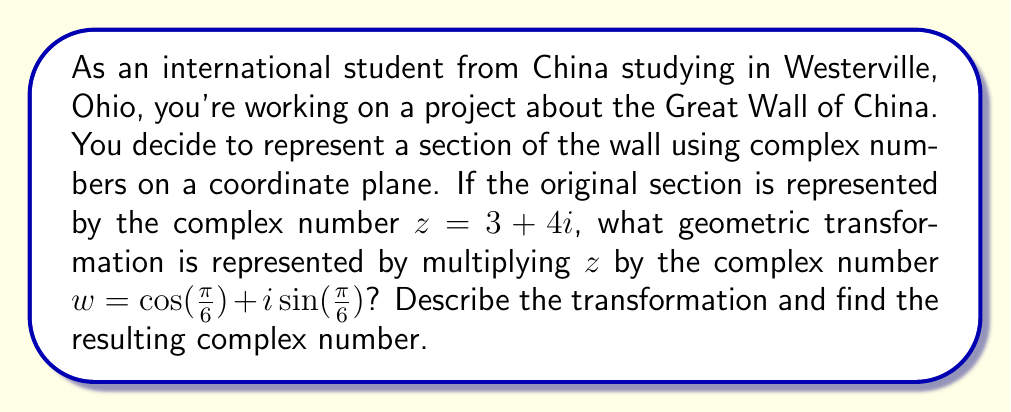Give your solution to this math problem. Let's approach this step-by-step:

1) Multiplying a complex number by another complex number represents a combination of rotation and dilation.

2) The complex number $w = \cos(\frac{\pi}{6}) + i\sin(\frac{\pi}{6})$ is in the form of $\cos\theta + i\sin\theta$, which represents a rotation by angle $\theta$ counterclockwise about the origin.

3) In this case, $\theta = \frac{\pi}{6} = 30°$, so multiplying by $w$ represents a rotation of 30° counterclockwise.

4) The magnitude of $w$ is:
   $$|w| = \sqrt{\cos^2(\frac{\pi}{6}) + \sin^2(\frac{\pi}{6})} = \sqrt{1} = 1$$

5) Since $|w| = 1$, there is no dilation (scaling) involved, only rotation.

6) To find the resulting complex number, we multiply $z$ by $w$:

   $$zw = (3 + 4i)(\cos(\frac{\pi}{6}) + i\sin(\frac{\pi}{6}))$$

7) Expanding this:
   $$zw = 3\cos(\frac{\pi}{6}) + 3i\sin(\frac{\pi}{6}) + 4i\cos(\frac{\pi}{6}) - 4\sin(\frac{\pi}{6})$$

8) Grouping real and imaginary parts:
   $$zw = (3\cos(\frac{\pi}{6}) - 4\sin(\frac{\pi}{6})) + i(3\sin(\frac{\pi}{6}) + 4\cos(\frac{\pi}{6}))$$

9) Calculating:
   $$\cos(\frac{\pi}{6}) = \frac{\sqrt{3}}{2}, \sin(\frac{\pi}{6}) = \frac{1}{2}$$

10) Substituting these values:
    $$zw = (3\cdot\frac{\sqrt{3}}{2} - 4\cdot\frac{1}{2}) + i(3\cdot\frac{1}{2} + 4\cdot\frac{\sqrt{3}}{2})$$
    $$= (\frac{3\sqrt{3}}{2} - 2) + i(\frac{3}{2} + 2\sqrt{3})$$
    $$\approx 2.60 + 4.96i$$
Answer: The geometric transformation represented by multiplying $z$ by $w$ is a rotation of 30° counterclockwise about the origin. The resulting complex number is approximately $2.60 + 4.96i$. 